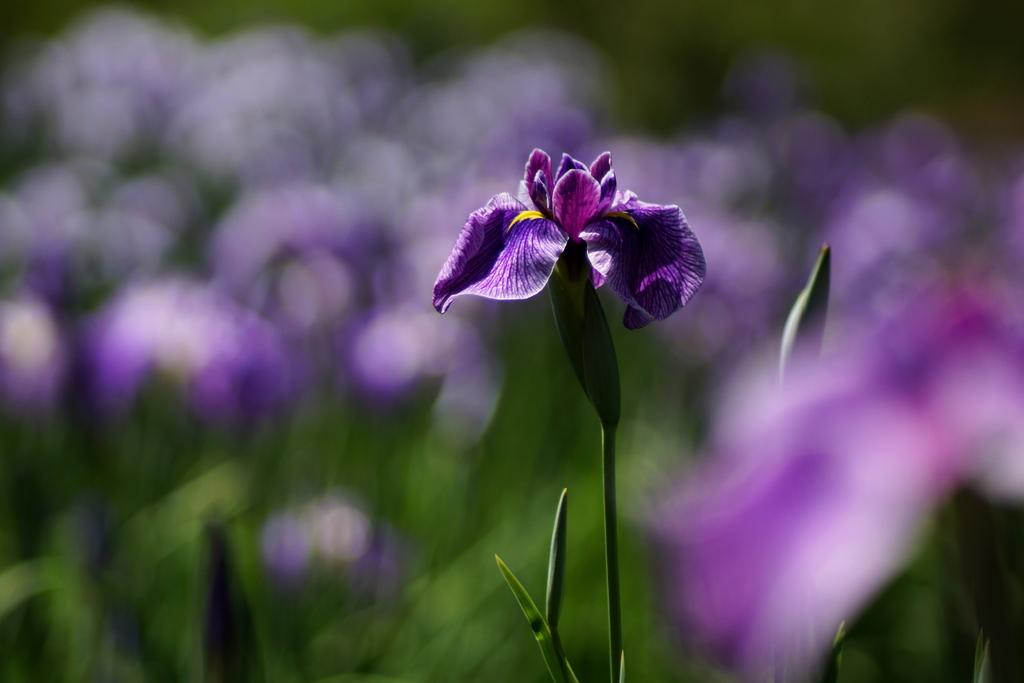What type of flower is visible in the image? There is a purple flower in the image. Where is the flower located? The flower is on a plant. Can you describe the background of the image? The background of the image is slightly blurry. How many tickets are needed to enter the flower in the image? There are no tickets mentioned or depicted in the image, as it features a purple flower on a plant with a blurry background. 